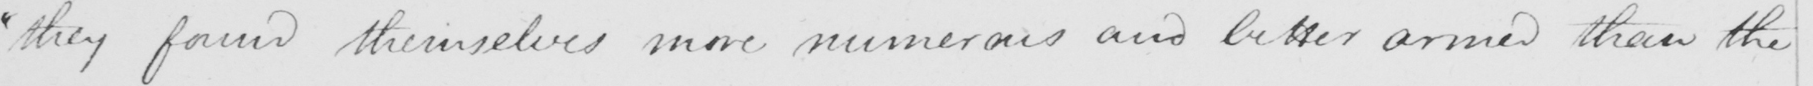What does this handwritten line say? " they found themselves more numerous and better armed than 